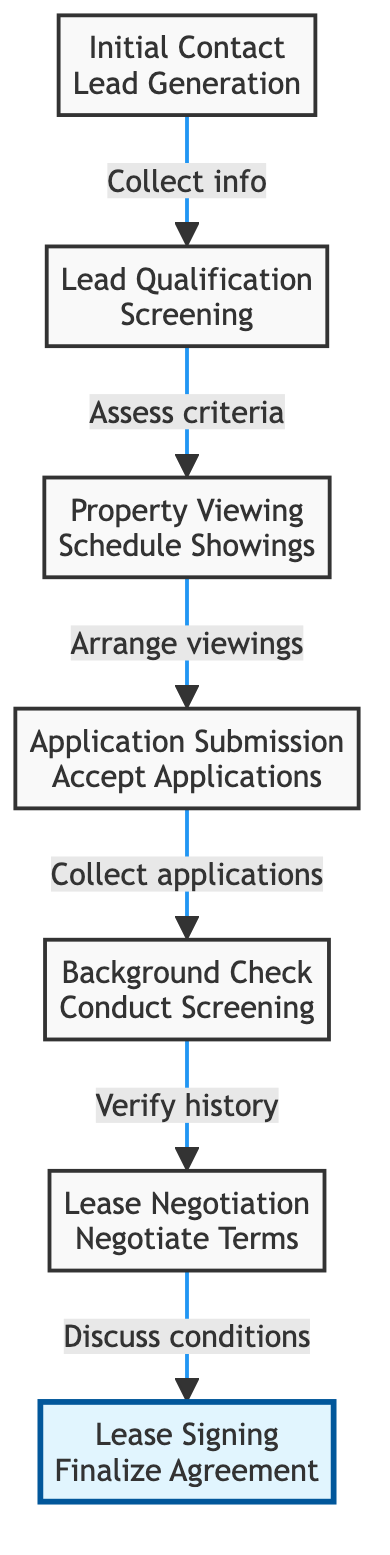What is the first step in the tenant acquisition funnel? The diagram indicates that the first step is "Initial Contact", which involves lead generation through various marketing campaigns.
Answer: Initial Contact How many steps are there in total? By counting the steps in the diagram from Initial Contact to Lease Signing, we find there are a total of 7 distinct steps.
Answer: 7 What action is associated with the "Lease Signing" step? According to the diagram, the action associated with the "Lease Signing" step is "Finalize Agreement".
Answer: Finalize Agreement Which step comes directly after "Application Submission"? Referring to the flow of the diagram, the step that follows "Application Submission" is "Background Check".
Answer: Background Check What is required during "Lead Qualification"? The diagram states that during "Lead Qualification", the necessary action is to "Screen" leads based on predefined criteria.
Answer: Screening What are the conditions being negotiated during "Lease Negotiation"? The step titled "Lease Negotiation" specifies that conditions such as the lease terms, monthly rent, and deposit are discussed with prospective tenants.
Answer: Lease terms, monthly rent, and deposit What is the relationship between "Property Viewing" and "Lead Qualification"? The relationship defined in the diagram indicates that "Property Viewing" follows "Lead Qualification" and involves scheduling showings for leads that have been qualified.
Answer: Property Viewing follows Lead Qualification Which step is represented by the highlighted node? The highlighted node at the top of the diagram is "Lease Signing", indicating its significance as the final step in the process.
Answer: Lease Signing What happens immediately before "Lease Signing"? The diagram shows that immediately before "Lease Signing" is "Lease Negotiation", where terms and conditions are discussed.
Answer: Lease Negotiation In which step is tenant history verified? The diagram states that tenant history is verified during the "Background Check" step, which includes various verifications of the tenant's background.
Answer: Background Check 